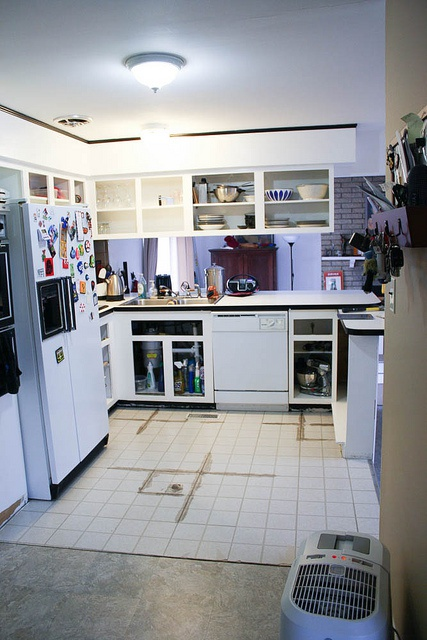Describe the objects in this image and their specific colors. I can see refrigerator in gray, lavender, and darkgray tones, sink in gray, darkgray, tan, and lightgray tones, bowl in gray, darkgray, and lightgray tones, bowl in gray, darkgray, and tan tones, and bowl in gray, navy, darkgray, and lightgray tones in this image. 